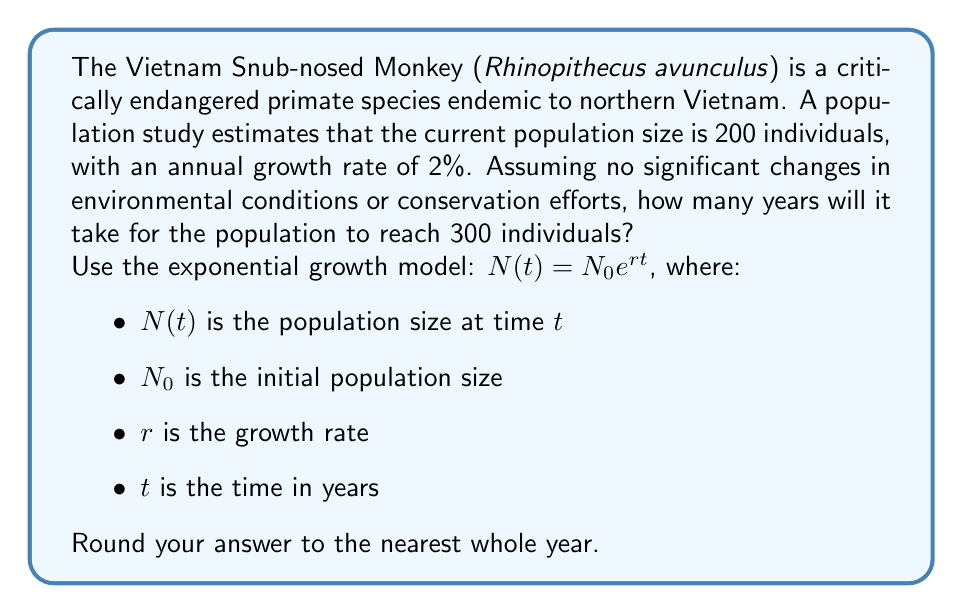Can you answer this question? To solve this problem, we'll use the exponential growth model and the given information:

1. Initial population size, $N_0 = 200$
2. Target population size, $N(t) = 300$
3. Annual growth rate, $r = 2\% = 0.02$

We need to find $t$ when $N(t) = 300$.

Let's substitute these values into the exponential growth equation:

$$300 = 200 e^{0.02t}$$

Now, we'll solve for $t$:

1. Divide both sides by 200:
   $$\frac{300}{200} = e^{0.02t}$$

2. Take the natural logarithm of both sides:
   $$\ln(\frac{300}{200}) = \ln(e^{0.02t})$$

3. Simplify the right side using the property of logarithms:
   $$\ln(\frac{300}{200}) = 0.02t$$

4. Solve for $t$:
   $$t = \frac{\ln(\frac{300}{200})}{0.02}$$

5. Calculate the result:
   $$t = \frac{\ln(1.5)}{0.02} \approx 20.27$$

6. Round to the nearest whole year:
   $t \approx 20$ years
Answer: 20 years 